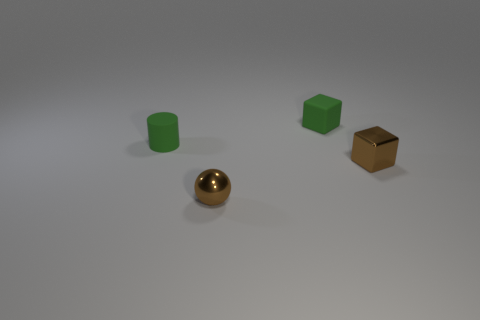How many objects are tiny metallic objects on the left side of the brown shiny block or matte objects behind the tiny rubber cylinder?
Give a very brief answer. 2. How many objects are cubes that are in front of the matte cube or blue rubber cylinders?
Provide a short and direct response. 1. There is a thing that is made of the same material as the green cube; what is its shape?
Your answer should be compact. Cylinder. What is the material of the ball?
Provide a short and direct response. Metal. There is a metal sphere; is it the same color as the tiny thing that is on the left side of the tiny metallic ball?
Make the answer very short. No. What number of blocks are shiny things or small green rubber objects?
Keep it short and to the point. 2. What color is the cube that is on the left side of the metallic block?
Make the answer very short. Green. What shape is the rubber thing that is the same color as the small matte cube?
Make the answer very short. Cylinder. How many green rubber things have the same size as the rubber block?
Provide a short and direct response. 1. Do the small brown shiny object left of the shiny cube and the tiny green rubber thing behind the small green rubber cylinder have the same shape?
Ensure brevity in your answer.  No. 